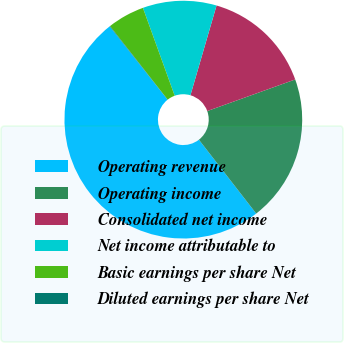<chart> <loc_0><loc_0><loc_500><loc_500><pie_chart><fcel>Operating revenue<fcel>Operating income<fcel>Consolidated net income<fcel>Net income attributable to<fcel>Basic earnings per share Net<fcel>Diluted earnings per share Net<nl><fcel>49.87%<fcel>19.99%<fcel>15.01%<fcel>10.03%<fcel>5.05%<fcel>0.07%<nl></chart> 